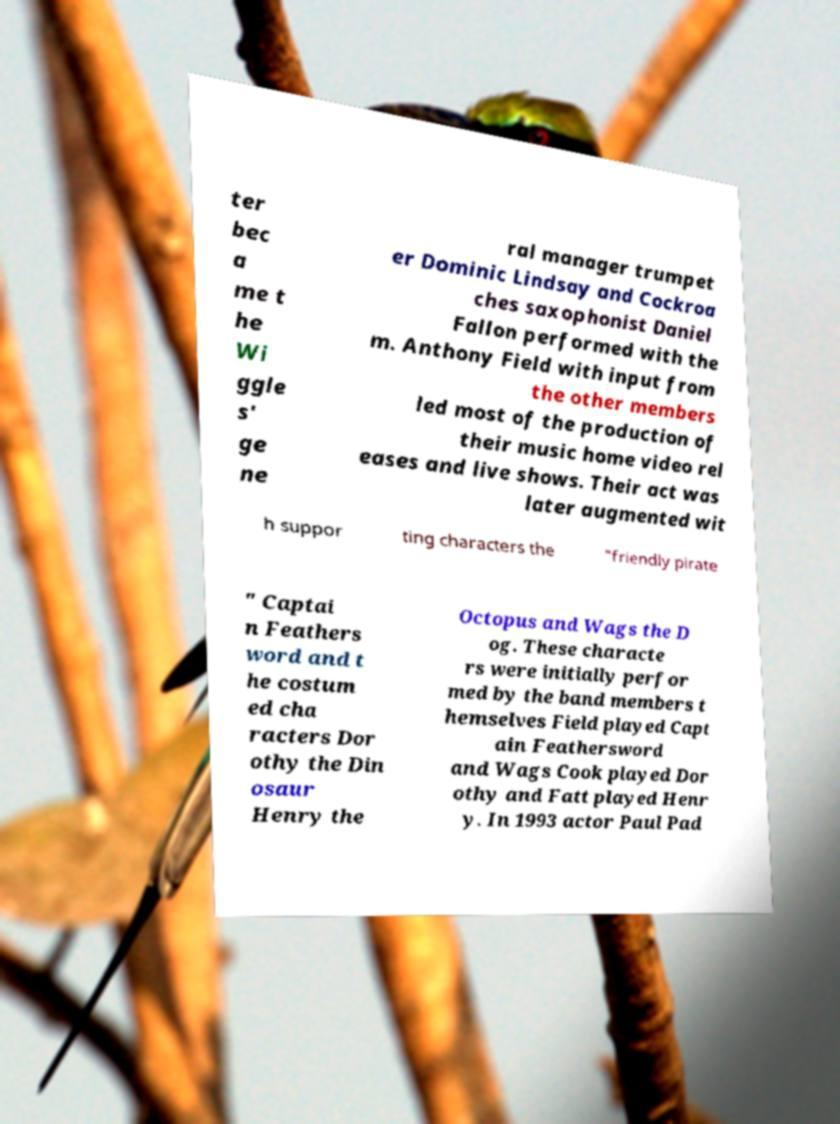Can you accurately transcribe the text from the provided image for me? ter bec a me t he Wi ggle s' ge ne ral manager trumpet er Dominic Lindsay and Cockroa ches saxophonist Daniel Fallon performed with the m. Anthony Field with input from the other members led most of the production of their music home video rel eases and live shows. Their act was later augmented wit h suppor ting characters the "friendly pirate " Captai n Feathers word and t he costum ed cha racters Dor othy the Din osaur Henry the Octopus and Wags the D og. These characte rs were initially perfor med by the band members t hemselves Field played Capt ain Feathersword and Wags Cook played Dor othy and Fatt played Henr y. In 1993 actor Paul Pad 